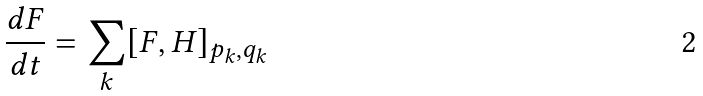Convert formula to latex. <formula><loc_0><loc_0><loc_500><loc_500>\frac { d F } { d t } = \sum _ { k } [ F , H ] _ { p _ { k } , q _ { k } }</formula> 